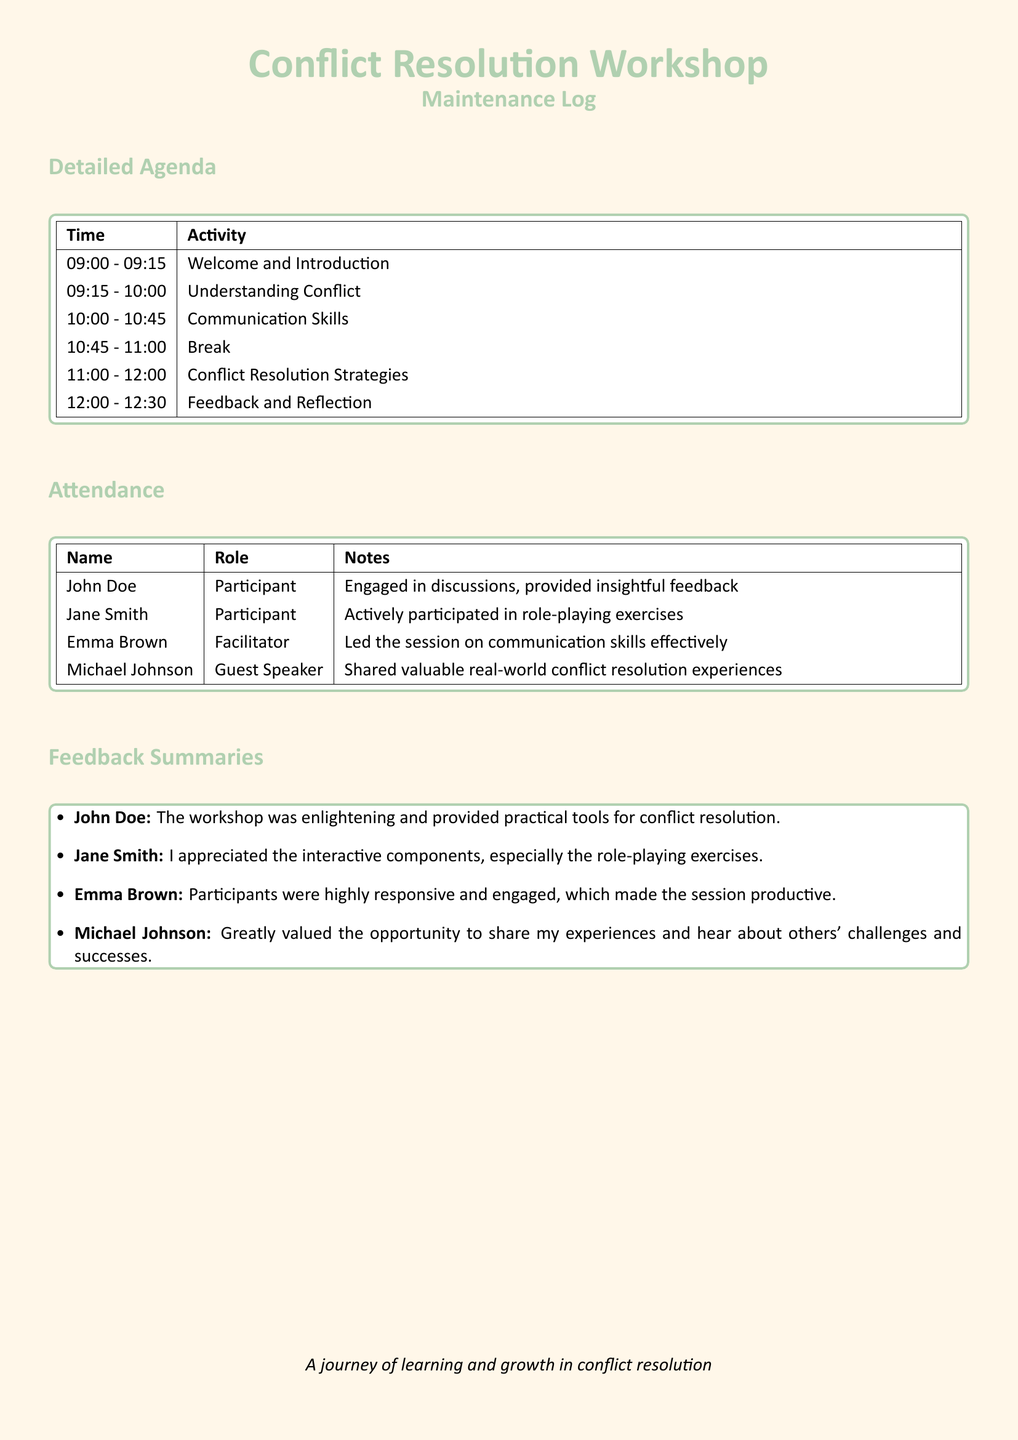What time does the workshop start? The workshop starts at 09:00, as indicated in the detailed agenda.
Answer: 09:00 Who was the guest speaker? The guest speaker listed in the attendance section is Michael Johnson.
Answer: Michael Johnson How long is the break scheduled for? The break is from 10:45 to 11:00, which is 15 minutes long.
Answer: 15 minutes Which activity had the longest duration? The activity on conflict resolution strategies lasts from 11:00 to 12:00, making it one hour long.
Answer: Conflict Resolution Strategies What was John Doe's feedback? John Doe mentioned that the workshop was enlightening and provided practical tools for conflict resolution.
Answer: Enlightening and provided practical tools Who led the session on communication skills? The facilitator for the communication skills session is Emma Brown, as noted in the attendance.
Answer: Emma Brown What aspect did Jane Smith appreciate the most? Jane Smith appreciated the interactive components, especially the role-playing exercises.
Answer: Interactive components How many total activity segments are listed in the agenda? There are a total of six activity segments outlined in the detailed agenda.
Answer: Six Which participant provided insightful feedback? The participant who provided insightful feedback is John Doe, according to the notes in the attendance section.
Answer: John Doe What is the primary purpose of this document? The primary purpose is to record details related to the Conflict Resolution Workshop's maintenance, including the agenda, attendance, and feedback.
Answer: Maintenance log 